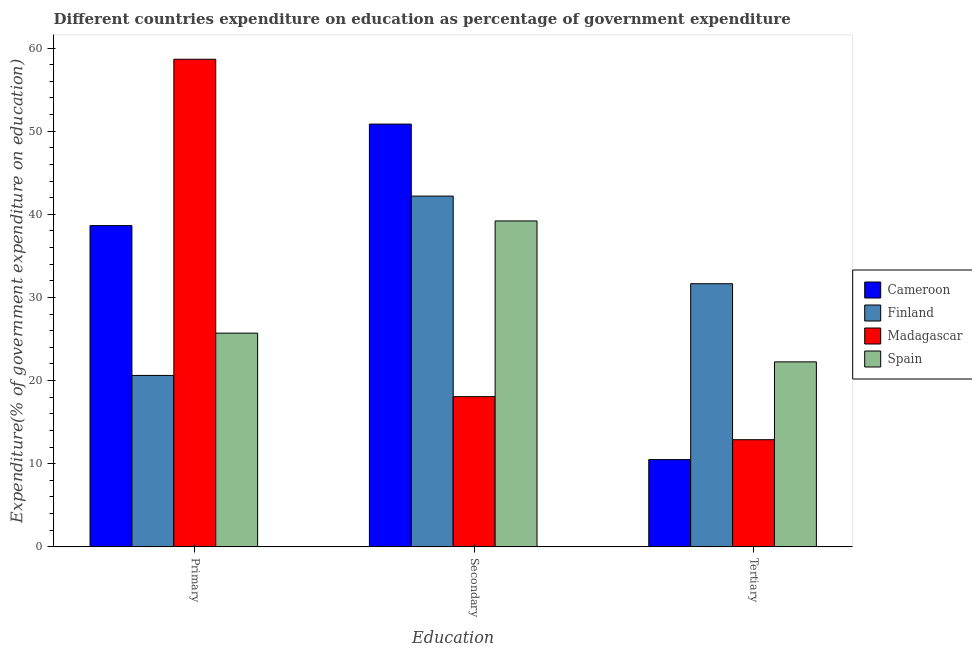How many different coloured bars are there?
Your response must be concise. 4. Are the number of bars per tick equal to the number of legend labels?
Your answer should be very brief. Yes. How many bars are there on the 2nd tick from the left?
Your response must be concise. 4. How many bars are there on the 3rd tick from the right?
Give a very brief answer. 4. What is the label of the 1st group of bars from the left?
Make the answer very short. Primary. What is the expenditure on primary education in Spain?
Keep it short and to the point. 25.71. Across all countries, what is the maximum expenditure on secondary education?
Your answer should be very brief. 50.86. Across all countries, what is the minimum expenditure on secondary education?
Your answer should be compact. 18.07. In which country was the expenditure on tertiary education maximum?
Ensure brevity in your answer.  Finland. In which country was the expenditure on secondary education minimum?
Make the answer very short. Madagascar. What is the total expenditure on primary education in the graph?
Keep it short and to the point. 143.63. What is the difference between the expenditure on tertiary education in Spain and that in Cameroon?
Your answer should be compact. 11.75. What is the difference between the expenditure on tertiary education in Madagascar and the expenditure on secondary education in Finland?
Keep it short and to the point. -29.3. What is the average expenditure on secondary education per country?
Provide a succinct answer. 37.58. What is the difference between the expenditure on secondary education and expenditure on primary education in Cameroon?
Make the answer very short. 12.21. What is the ratio of the expenditure on secondary education in Finland to that in Cameroon?
Make the answer very short. 0.83. Is the expenditure on tertiary education in Cameroon less than that in Finland?
Keep it short and to the point. Yes. What is the difference between the highest and the second highest expenditure on primary education?
Offer a terse response. 20.01. What is the difference between the highest and the lowest expenditure on tertiary education?
Offer a terse response. 21.15. What does the 3rd bar from the left in Tertiary represents?
Provide a short and direct response. Madagascar. Are the values on the major ticks of Y-axis written in scientific E-notation?
Give a very brief answer. No. Where does the legend appear in the graph?
Offer a very short reply. Center right. How many legend labels are there?
Offer a very short reply. 4. What is the title of the graph?
Offer a terse response. Different countries expenditure on education as percentage of government expenditure. Does "Sri Lanka" appear as one of the legend labels in the graph?
Provide a succinct answer. No. What is the label or title of the X-axis?
Offer a very short reply. Education. What is the label or title of the Y-axis?
Offer a terse response. Expenditure(% of government expenditure on education). What is the Expenditure(% of government expenditure on education) of Cameroon in Primary?
Offer a terse response. 38.65. What is the Expenditure(% of government expenditure on education) in Finland in Primary?
Offer a terse response. 20.62. What is the Expenditure(% of government expenditure on education) of Madagascar in Primary?
Your answer should be compact. 58.65. What is the Expenditure(% of government expenditure on education) of Spain in Primary?
Provide a succinct answer. 25.71. What is the Expenditure(% of government expenditure on education) of Cameroon in Secondary?
Offer a terse response. 50.86. What is the Expenditure(% of government expenditure on education) of Finland in Secondary?
Your answer should be compact. 42.19. What is the Expenditure(% of government expenditure on education) in Madagascar in Secondary?
Provide a succinct answer. 18.07. What is the Expenditure(% of government expenditure on education) in Spain in Secondary?
Make the answer very short. 39.2. What is the Expenditure(% of government expenditure on education) in Cameroon in Tertiary?
Your answer should be very brief. 10.5. What is the Expenditure(% of government expenditure on education) in Finland in Tertiary?
Give a very brief answer. 31.65. What is the Expenditure(% of government expenditure on education) in Madagascar in Tertiary?
Keep it short and to the point. 12.89. What is the Expenditure(% of government expenditure on education) of Spain in Tertiary?
Your answer should be very brief. 22.25. Across all Education, what is the maximum Expenditure(% of government expenditure on education) of Cameroon?
Provide a succinct answer. 50.86. Across all Education, what is the maximum Expenditure(% of government expenditure on education) in Finland?
Ensure brevity in your answer.  42.19. Across all Education, what is the maximum Expenditure(% of government expenditure on education) of Madagascar?
Your answer should be compact. 58.65. Across all Education, what is the maximum Expenditure(% of government expenditure on education) in Spain?
Your answer should be very brief. 39.2. Across all Education, what is the minimum Expenditure(% of government expenditure on education) in Cameroon?
Provide a succinct answer. 10.5. Across all Education, what is the minimum Expenditure(% of government expenditure on education) in Finland?
Keep it short and to the point. 20.62. Across all Education, what is the minimum Expenditure(% of government expenditure on education) of Madagascar?
Your response must be concise. 12.89. Across all Education, what is the minimum Expenditure(% of government expenditure on education) in Spain?
Provide a succinct answer. 22.25. What is the total Expenditure(% of government expenditure on education) in Cameroon in the graph?
Keep it short and to the point. 100. What is the total Expenditure(% of government expenditure on education) in Finland in the graph?
Your response must be concise. 94.47. What is the total Expenditure(% of government expenditure on education) in Madagascar in the graph?
Your response must be concise. 89.61. What is the total Expenditure(% of government expenditure on education) in Spain in the graph?
Keep it short and to the point. 87.16. What is the difference between the Expenditure(% of government expenditure on education) of Cameroon in Primary and that in Secondary?
Your answer should be very brief. -12.21. What is the difference between the Expenditure(% of government expenditure on education) in Finland in Primary and that in Secondary?
Provide a short and direct response. -21.57. What is the difference between the Expenditure(% of government expenditure on education) of Madagascar in Primary and that in Secondary?
Your answer should be compact. 40.59. What is the difference between the Expenditure(% of government expenditure on education) of Spain in Primary and that in Secondary?
Give a very brief answer. -13.5. What is the difference between the Expenditure(% of government expenditure on education) of Cameroon in Primary and that in Tertiary?
Keep it short and to the point. 28.15. What is the difference between the Expenditure(% of government expenditure on education) of Finland in Primary and that in Tertiary?
Ensure brevity in your answer.  -11.03. What is the difference between the Expenditure(% of government expenditure on education) in Madagascar in Primary and that in Tertiary?
Give a very brief answer. 45.77. What is the difference between the Expenditure(% of government expenditure on education) of Spain in Primary and that in Tertiary?
Provide a succinct answer. 3.45. What is the difference between the Expenditure(% of government expenditure on education) of Cameroon in Secondary and that in Tertiary?
Give a very brief answer. 40.36. What is the difference between the Expenditure(% of government expenditure on education) in Finland in Secondary and that in Tertiary?
Provide a succinct answer. 10.54. What is the difference between the Expenditure(% of government expenditure on education) in Madagascar in Secondary and that in Tertiary?
Your answer should be compact. 5.18. What is the difference between the Expenditure(% of government expenditure on education) of Spain in Secondary and that in Tertiary?
Keep it short and to the point. 16.95. What is the difference between the Expenditure(% of government expenditure on education) of Cameroon in Primary and the Expenditure(% of government expenditure on education) of Finland in Secondary?
Ensure brevity in your answer.  -3.55. What is the difference between the Expenditure(% of government expenditure on education) of Cameroon in Primary and the Expenditure(% of government expenditure on education) of Madagascar in Secondary?
Offer a very short reply. 20.58. What is the difference between the Expenditure(% of government expenditure on education) in Cameroon in Primary and the Expenditure(% of government expenditure on education) in Spain in Secondary?
Provide a short and direct response. -0.56. What is the difference between the Expenditure(% of government expenditure on education) of Finland in Primary and the Expenditure(% of government expenditure on education) of Madagascar in Secondary?
Offer a very short reply. 2.55. What is the difference between the Expenditure(% of government expenditure on education) in Finland in Primary and the Expenditure(% of government expenditure on education) in Spain in Secondary?
Offer a terse response. -18.58. What is the difference between the Expenditure(% of government expenditure on education) in Madagascar in Primary and the Expenditure(% of government expenditure on education) in Spain in Secondary?
Make the answer very short. 19.45. What is the difference between the Expenditure(% of government expenditure on education) in Cameroon in Primary and the Expenditure(% of government expenditure on education) in Finland in Tertiary?
Your answer should be compact. 6.99. What is the difference between the Expenditure(% of government expenditure on education) of Cameroon in Primary and the Expenditure(% of government expenditure on education) of Madagascar in Tertiary?
Your answer should be compact. 25.76. What is the difference between the Expenditure(% of government expenditure on education) in Cameroon in Primary and the Expenditure(% of government expenditure on education) in Spain in Tertiary?
Offer a very short reply. 16.39. What is the difference between the Expenditure(% of government expenditure on education) of Finland in Primary and the Expenditure(% of government expenditure on education) of Madagascar in Tertiary?
Provide a short and direct response. 7.73. What is the difference between the Expenditure(% of government expenditure on education) of Finland in Primary and the Expenditure(% of government expenditure on education) of Spain in Tertiary?
Offer a terse response. -1.63. What is the difference between the Expenditure(% of government expenditure on education) of Madagascar in Primary and the Expenditure(% of government expenditure on education) of Spain in Tertiary?
Offer a terse response. 36.4. What is the difference between the Expenditure(% of government expenditure on education) of Cameroon in Secondary and the Expenditure(% of government expenditure on education) of Finland in Tertiary?
Your response must be concise. 19.2. What is the difference between the Expenditure(% of government expenditure on education) of Cameroon in Secondary and the Expenditure(% of government expenditure on education) of Madagascar in Tertiary?
Your response must be concise. 37.97. What is the difference between the Expenditure(% of government expenditure on education) of Cameroon in Secondary and the Expenditure(% of government expenditure on education) of Spain in Tertiary?
Offer a very short reply. 28.6. What is the difference between the Expenditure(% of government expenditure on education) of Finland in Secondary and the Expenditure(% of government expenditure on education) of Madagascar in Tertiary?
Provide a succinct answer. 29.3. What is the difference between the Expenditure(% of government expenditure on education) of Finland in Secondary and the Expenditure(% of government expenditure on education) of Spain in Tertiary?
Keep it short and to the point. 19.94. What is the difference between the Expenditure(% of government expenditure on education) in Madagascar in Secondary and the Expenditure(% of government expenditure on education) in Spain in Tertiary?
Offer a very short reply. -4.18. What is the average Expenditure(% of government expenditure on education) of Cameroon per Education?
Provide a succinct answer. 33.33. What is the average Expenditure(% of government expenditure on education) of Finland per Education?
Ensure brevity in your answer.  31.49. What is the average Expenditure(% of government expenditure on education) of Madagascar per Education?
Ensure brevity in your answer.  29.87. What is the average Expenditure(% of government expenditure on education) of Spain per Education?
Keep it short and to the point. 29.05. What is the difference between the Expenditure(% of government expenditure on education) in Cameroon and Expenditure(% of government expenditure on education) in Finland in Primary?
Offer a terse response. 18.03. What is the difference between the Expenditure(% of government expenditure on education) in Cameroon and Expenditure(% of government expenditure on education) in Madagascar in Primary?
Keep it short and to the point. -20.01. What is the difference between the Expenditure(% of government expenditure on education) in Cameroon and Expenditure(% of government expenditure on education) in Spain in Primary?
Keep it short and to the point. 12.94. What is the difference between the Expenditure(% of government expenditure on education) in Finland and Expenditure(% of government expenditure on education) in Madagascar in Primary?
Ensure brevity in your answer.  -38.03. What is the difference between the Expenditure(% of government expenditure on education) in Finland and Expenditure(% of government expenditure on education) in Spain in Primary?
Your answer should be very brief. -5.09. What is the difference between the Expenditure(% of government expenditure on education) in Madagascar and Expenditure(% of government expenditure on education) in Spain in Primary?
Your answer should be very brief. 32.95. What is the difference between the Expenditure(% of government expenditure on education) in Cameroon and Expenditure(% of government expenditure on education) in Finland in Secondary?
Your response must be concise. 8.66. What is the difference between the Expenditure(% of government expenditure on education) of Cameroon and Expenditure(% of government expenditure on education) of Madagascar in Secondary?
Offer a very short reply. 32.79. What is the difference between the Expenditure(% of government expenditure on education) of Cameroon and Expenditure(% of government expenditure on education) of Spain in Secondary?
Your answer should be very brief. 11.65. What is the difference between the Expenditure(% of government expenditure on education) in Finland and Expenditure(% of government expenditure on education) in Madagascar in Secondary?
Keep it short and to the point. 24.12. What is the difference between the Expenditure(% of government expenditure on education) in Finland and Expenditure(% of government expenditure on education) in Spain in Secondary?
Your answer should be compact. 2.99. What is the difference between the Expenditure(% of government expenditure on education) in Madagascar and Expenditure(% of government expenditure on education) in Spain in Secondary?
Your response must be concise. -21.13. What is the difference between the Expenditure(% of government expenditure on education) of Cameroon and Expenditure(% of government expenditure on education) of Finland in Tertiary?
Ensure brevity in your answer.  -21.15. What is the difference between the Expenditure(% of government expenditure on education) of Cameroon and Expenditure(% of government expenditure on education) of Madagascar in Tertiary?
Your answer should be very brief. -2.39. What is the difference between the Expenditure(% of government expenditure on education) in Cameroon and Expenditure(% of government expenditure on education) in Spain in Tertiary?
Provide a succinct answer. -11.75. What is the difference between the Expenditure(% of government expenditure on education) of Finland and Expenditure(% of government expenditure on education) of Madagascar in Tertiary?
Your response must be concise. 18.76. What is the difference between the Expenditure(% of government expenditure on education) of Finland and Expenditure(% of government expenditure on education) of Spain in Tertiary?
Offer a very short reply. 9.4. What is the difference between the Expenditure(% of government expenditure on education) in Madagascar and Expenditure(% of government expenditure on education) in Spain in Tertiary?
Your response must be concise. -9.36. What is the ratio of the Expenditure(% of government expenditure on education) of Cameroon in Primary to that in Secondary?
Your response must be concise. 0.76. What is the ratio of the Expenditure(% of government expenditure on education) in Finland in Primary to that in Secondary?
Your answer should be compact. 0.49. What is the ratio of the Expenditure(% of government expenditure on education) in Madagascar in Primary to that in Secondary?
Provide a succinct answer. 3.25. What is the ratio of the Expenditure(% of government expenditure on education) of Spain in Primary to that in Secondary?
Ensure brevity in your answer.  0.66. What is the ratio of the Expenditure(% of government expenditure on education) in Cameroon in Primary to that in Tertiary?
Offer a terse response. 3.68. What is the ratio of the Expenditure(% of government expenditure on education) in Finland in Primary to that in Tertiary?
Offer a terse response. 0.65. What is the ratio of the Expenditure(% of government expenditure on education) in Madagascar in Primary to that in Tertiary?
Offer a terse response. 4.55. What is the ratio of the Expenditure(% of government expenditure on education) in Spain in Primary to that in Tertiary?
Offer a very short reply. 1.16. What is the ratio of the Expenditure(% of government expenditure on education) in Cameroon in Secondary to that in Tertiary?
Your response must be concise. 4.84. What is the ratio of the Expenditure(% of government expenditure on education) in Finland in Secondary to that in Tertiary?
Offer a very short reply. 1.33. What is the ratio of the Expenditure(% of government expenditure on education) of Madagascar in Secondary to that in Tertiary?
Your answer should be compact. 1.4. What is the ratio of the Expenditure(% of government expenditure on education) in Spain in Secondary to that in Tertiary?
Ensure brevity in your answer.  1.76. What is the difference between the highest and the second highest Expenditure(% of government expenditure on education) in Cameroon?
Provide a short and direct response. 12.21. What is the difference between the highest and the second highest Expenditure(% of government expenditure on education) in Finland?
Provide a succinct answer. 10.54. What is the difference between the highest and the second highest Expenditure(% of government expenditure on education) of Madagascar?
Your answer should be very brief. 40.59. What is the difference between the highest and the second highest Expenditure(% of government expenditure on education) in Spain?
Offer a terse response. 13.5. What is the difference between the highest and the lowest Expenditure(% of government expenditure on education) in Cameroon?
Offer a very short reply. 40.36. What is the difference between the highest and the lowest Expenditure(% of government expenditure on education) in Finland?
Your answer should be compact. 21.57. What is the difference between the highest and the lowest Expenditure(% of government expenditure on education) in Madagascar?
Make the answer very short. 45.77. What is the difference between the highest and the lowest Expenditure(% of government expenditure on education) in Spain?
Give a very brief answer. 16.95. 